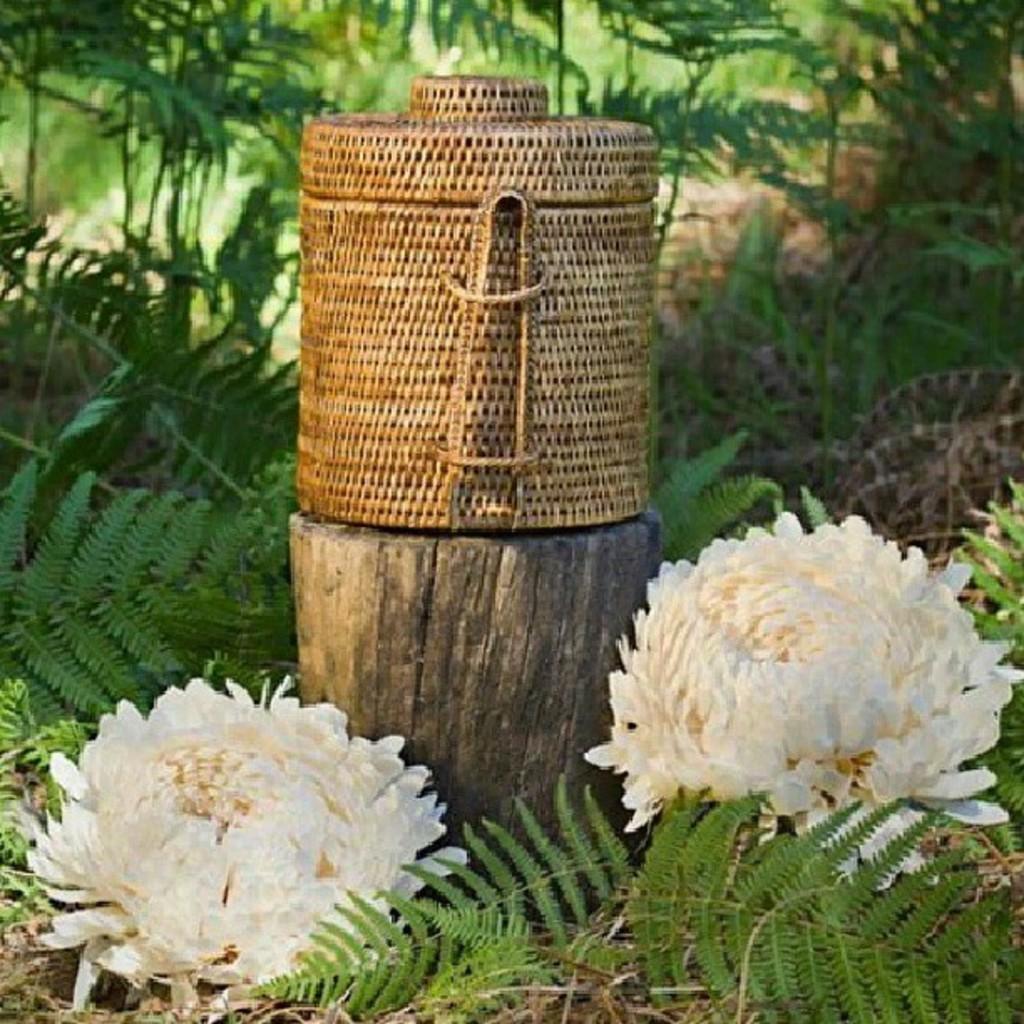How would you summarize this image in a sentence or two? In this image in the center there is one basket and a wooden pole, at the bottom there are some flowers and plants. In the background there are some trees. 